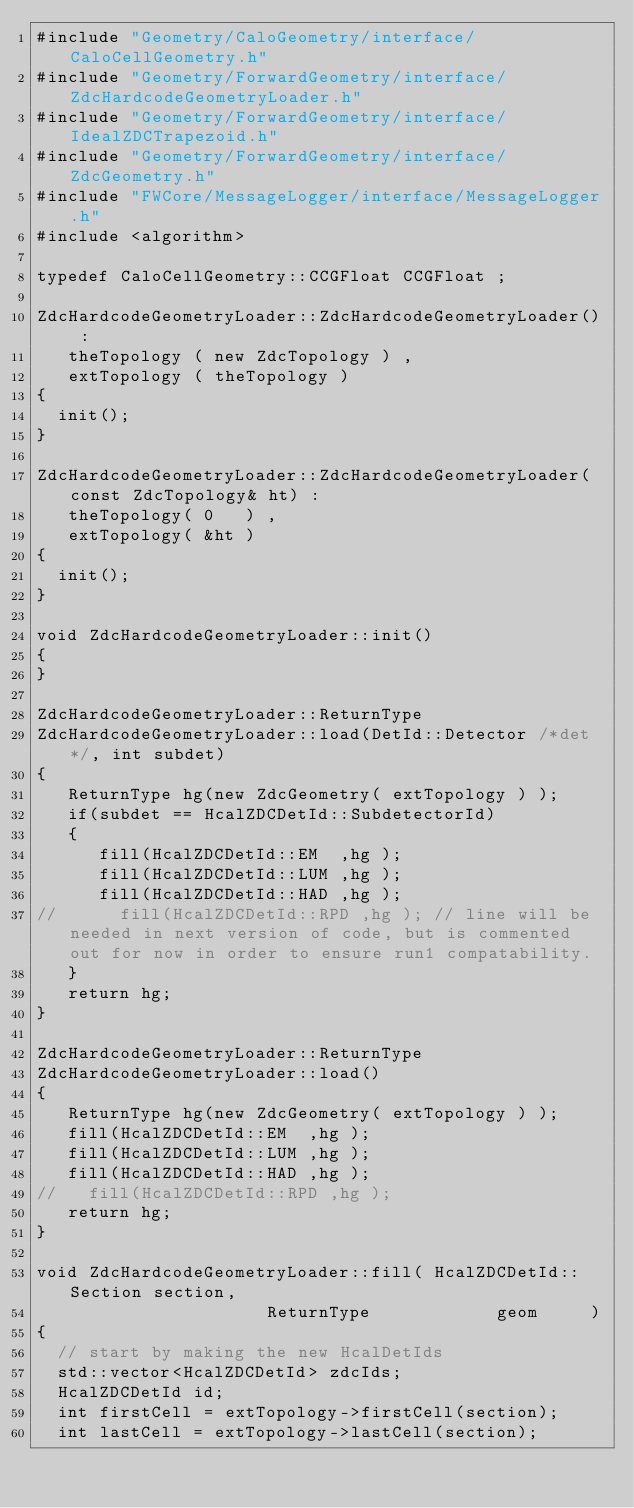Convert code to text. <code><loc_0><loc_0><loc_500><loc_500><_C++_>#include "Geometry/CaloGeometry/interface/CaloCellGeometry.h"
#include "Geometry/ForwardGeometry/interface/ZdcHardcodeGeometryLoader.h"
#include "Geometry/ForwardGeometry/interface/IdealZDCTrapezoid.h"
#include "Geometry/ForwardGeometry/interface/ZdcGeometry.h"
#include "FWCore/MessageLogger/interface/MessageLogger.h"
#include <algorithm>

typedef CaloCellGeometry::CCGFloat CCGFloat ;

ZdcHardcodeGeometryLoader::ZdcHardcodeGeometryLoader() :
   theTopology ( new ZdcTopology ) ,
   extTopology ( theTopology )
{
  init();
}

ZdcHardcodeGeometryLoader::ZdcHardcodeGeometryLoader(const ZdcTopology& ht) : 
   theTopology( 0   ) ,
   extTopology( &ht ) 
{
  init();
}

void ZdcHardcodeGeometryLoader::init() 
{
}

ZdcHardcodeGeometryLoader::ReturnType 
ZdcHardcodeGeometryLoader::load(DetId::Detector /*det*/, int subdet)
{
   ReturnType hg(new ZdcGeometry( extTopology ) );
   if(subdet == HcalZDCDetId::SubdetectorId)
   {
      fill(HcalZDCDetId::EM  ,hg );
      fill(HcalZDCDetId::LUM ,hg );
      fill(HcalZDCDetId::HAD ,hg );
//      fill(HcalZDCDetId::RPD ,hg ); // line will be needed in next version of code, but is commented out for now in order to ensure run1 compatability. 
   }
   return hg;
}

ZdcHardcodeGeometryLoader::ReturnType 
ZdcHardcodeGeometryLoader::load() 
{
   ReturnType hg(new ZdcGeometry( extTopology ) );
   fill(HcalZDCDetId::EM  ,hg );
   fill(HcalZDCDetId::LUM ,hg );
   fill(HcalZDCDetId::HAD ,hg );
//   fill(HcalZDCDetId::RPD ,hg );
   return hg;
}

void ZdcHardcodeGeometryLoader::fill( HcalZDCDetId::Section section, 
				      ReturnType            geom     ) 
{
  // start by making the new HcalDetIds
  std::vector<HcalZDCDetId> zdcIds;
  HcalZDCDetId id;
  int firstCell = extTopology->firstCell(section);
  int lastCell = extTopology->lastCell(section);</code> 